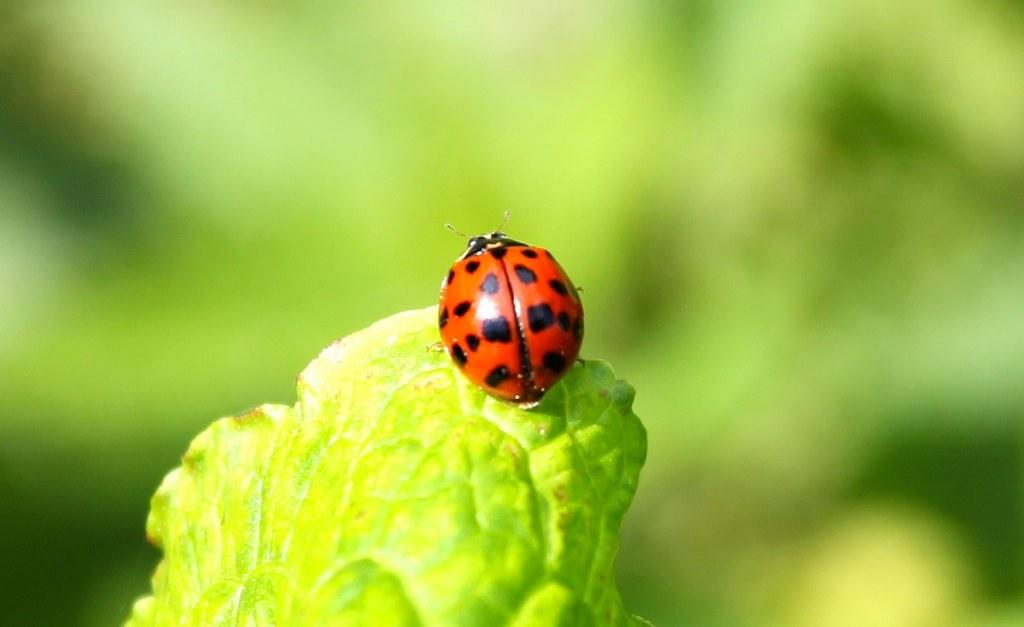What insect is present in the image? There is a ladybug in the image. What is the ladybug resting on? The ladybug is on a green object. Can you describe the background of the image? The background of the image is green and blurry. What flavor of breath can be smelled in the image? There is no mention of breath or any specific scent in the image, so it cannot be determined. 